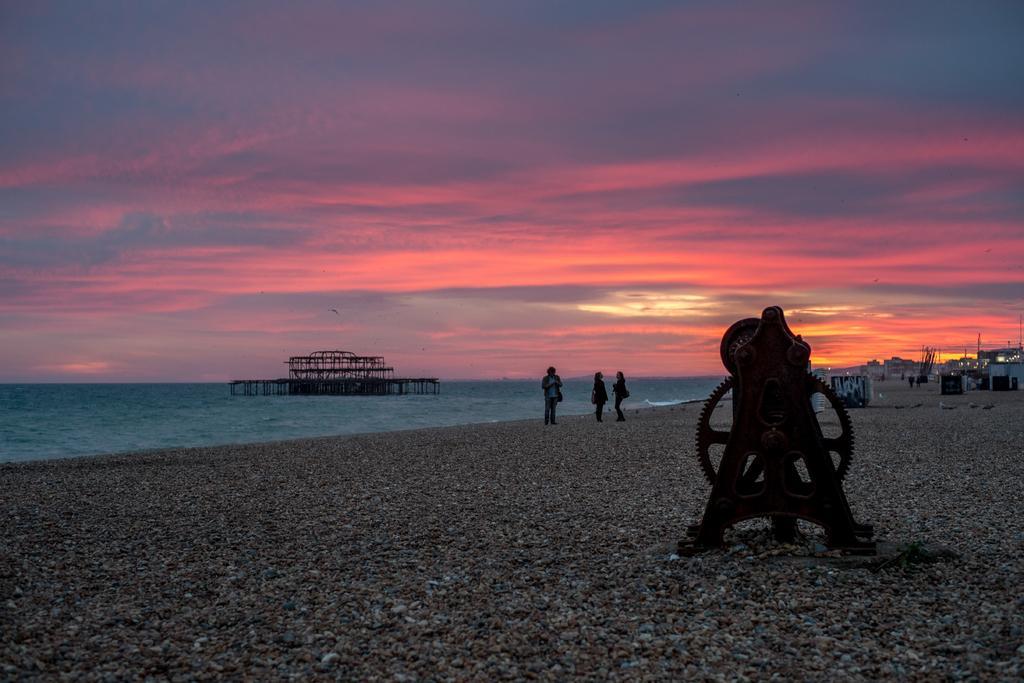Describe this image in one or two sentences. This picture is clicked outside. On the right we can see the gravel and a metal object is placed on the ground. In the center we can see the group of people seems to be wearing sling bags and standing on the ground. In the background we can see the sky and we can see the birds like objects seems to be flying in the sky. In the center there is an object which seems to be the bridge in the water body. On the right we can see the buildings, people like objects and many other objects. 